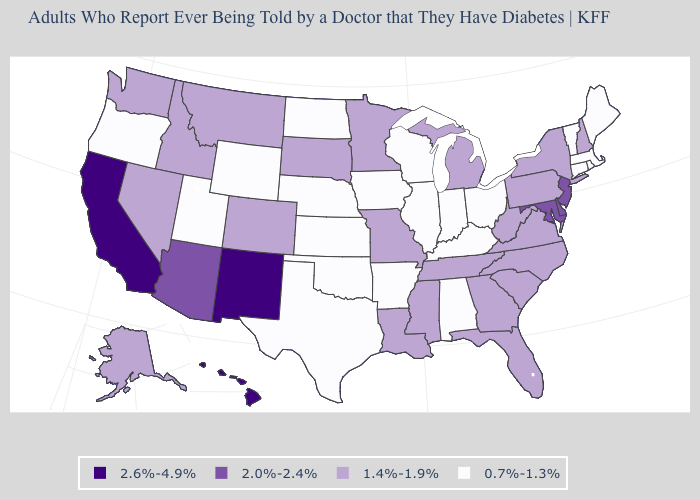What is the value of Massachusetts?
Quick response, please. 0.7%-1.3%. What is the value of New Hampshire?
Keep it brief. 1.4%-1.9%. Is the legend a continuous bar?
Give a very brief answer. No. Which states have the lowest value in the USA?
Answer briefly. Alabama, Arkansas, Connecticut, Illinois, Indiana, Iowa, Kansas, Kentucky, Maine, Massachusetts, Nebraska, North Dakota, Ohio, Oklahoma, Oregon, Rhode Island, Texas, Utah, Vermont, Wisconsin, Wyoming. What is the highest value in the USA?
Answer briefly. 2.6%-4.9%. Does the first symbol in the legend represent the smallest category?
Keep it brief. No. What is the value of New Jersey?
Concise answer only. 2.0%-2.4%. Is the legend a continuous bar?
Keep it brief. No. What is the highest value in the USA?
Give a very brief answer. 2.6%-4.9%. Name the states that have a value in the range 2.0%-2.4%?
Keep it brief. Arizona, Delaware, Maryland, New Jersey. Does Connecticut have the lowest value in the USA?
Quick response, please. Yes. What is the value of Virginia?
Short answer required. 1.4%-1.9%. Which states hav the highest value in the Northeast?
Concise answer only. New Jersey. Does the first symbol in the legend represent the smallest category?
Concise answer only. No. Does Massachusetts have the lowest value in the USA?
Write a very short answer. Yes. 